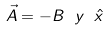<formula> <loc_0><loc_0><loc_500><loc_500>\vec { A } = - B \ y \ \hat { x }</formula> 